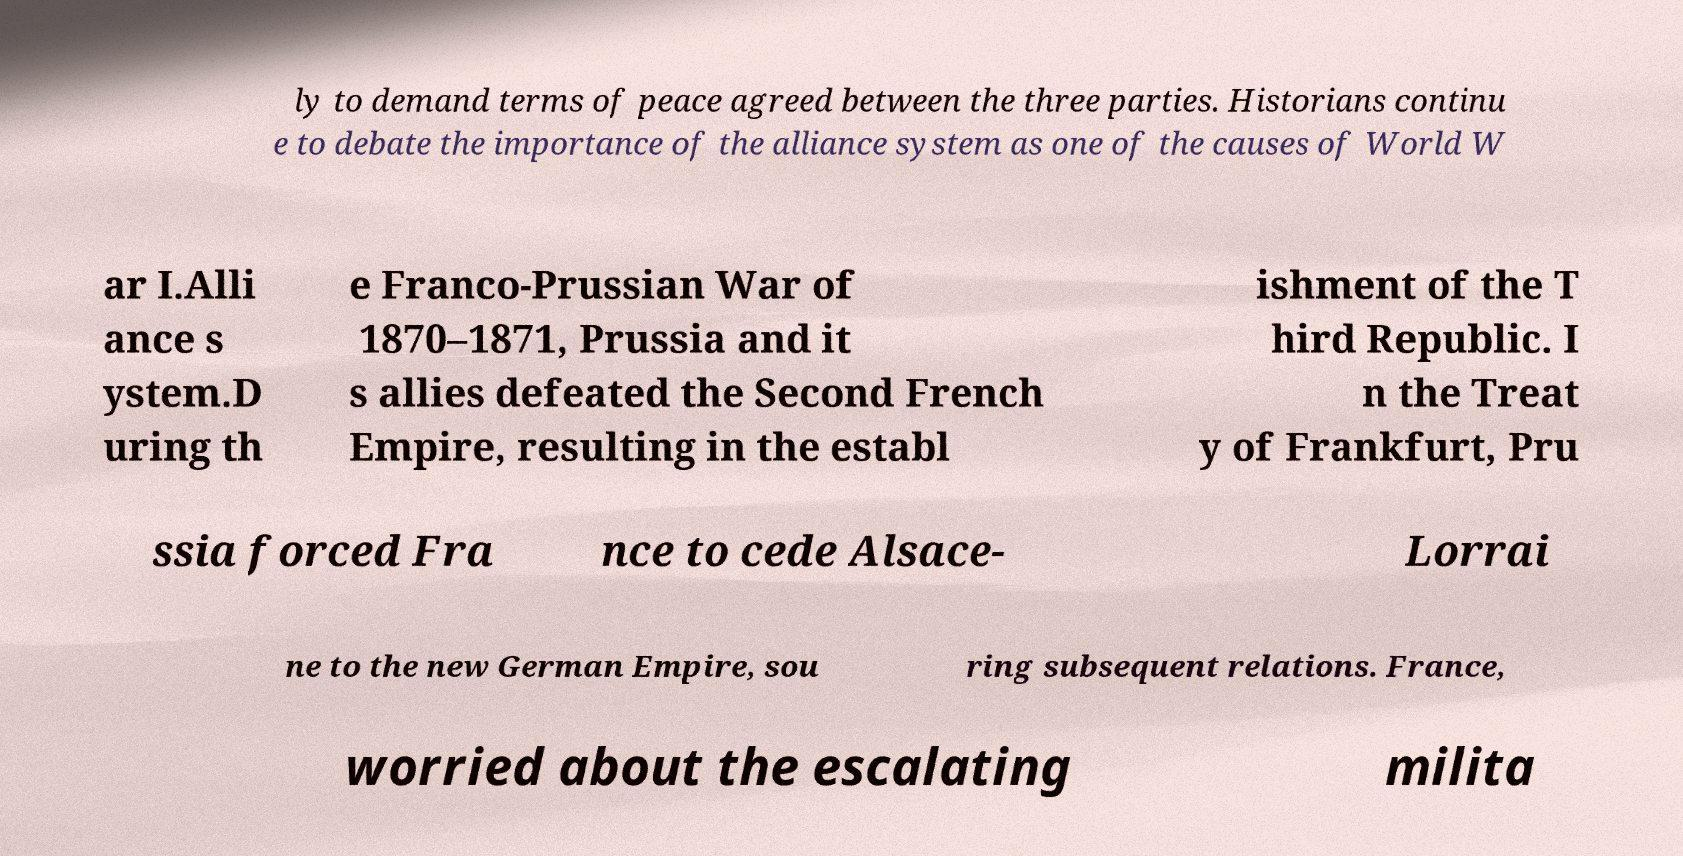Could you extract and type out the text from this image? ly to demand terms of peace agreed between the three parties. Historians continu e to debate the importance of the alliance system as one of the causes of World W ar I.Alli ance s ystem.D uring th e Franco-Prussian War of 1870–1871, Prussia and it s allies defeated the Second French Empire, resulting in the establ ishment of the T hird Republic. I n the Treat y of Frankfurt, Pru ssia forced Fra nce to cede Alsace- Lorrai ne to the new German Empire, sou ring subsequent relations. France, worried about the escalating milita 